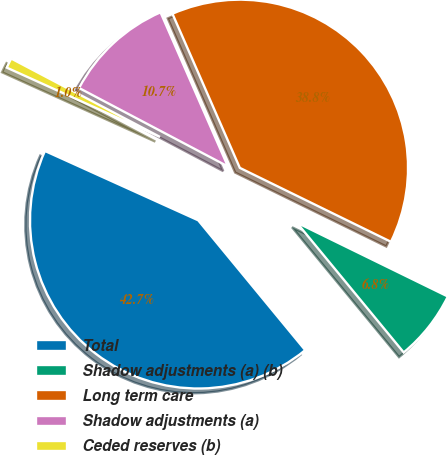<chart> <loc_0><loc_0><loc_500><loc_500><pie_chart><fcel>Total<fcel>Shadow adjustments (a) (b)<fcel>Long term care<fcel>Shadow adjustments (a)<fcel>Ceded reserves (b)<nl><fcel>42.73%<fcel>6.79%<fcel>38.8%<fcel>10.72%<fcel>0.96%<nl></chart> 